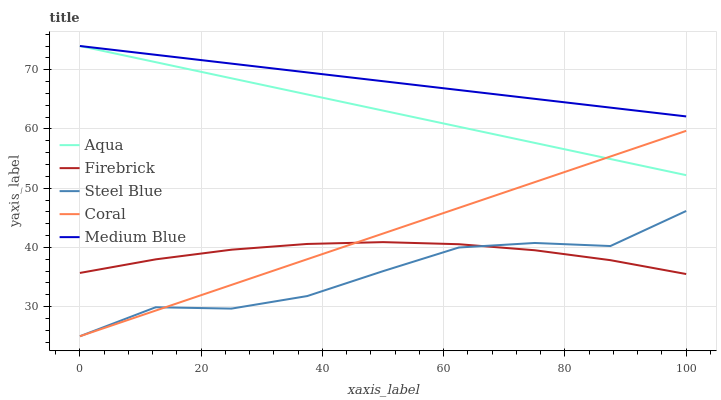Does Steel Blue have the minimum area under the curve?
Answer yes or no. Yes. Does Medium Blue have the maximum area under the curve?
Answer yes or no. Yes. Does Firebrick have the minimum area under the curve?
Answer yes or no. No. Does Firebrick have the maximum area under the curve?
Answer yes or no. No. Is Coral the smoothest?
Answer yes or no. Yes. Is Steel Blue the roughest?
Answer yes or no. Yes. Is Medium Blue the smoothest?
Answer yes or no. No. Is Medium Blue the roughest?
Answer yes or no. No. Does Coral have the lowest value?
Answer yes or no. Yes. Does Firebrick have the lowest value?
Answer yes or no. No. Does Aqua have the highest value?
Answer yes or no. Yes. Does Firebrick have the highest value?
Answer yes or no. No. Is Steel Blue less than Medium Blue?
Answer yes or no. Yes. Is Medium Blue greater than Firebrick?
Answer yes or no. Yes. Does Coral intersect Steel Blue?
Answer yes or no. Yes. Is Coral less than Steel Blue?
Answer yes or no. No. Is Coral greater than Steel Blue?
Answer yes or no. No. Does Steel Blue intersect Medium Blue?
Answer yes or no. No. 